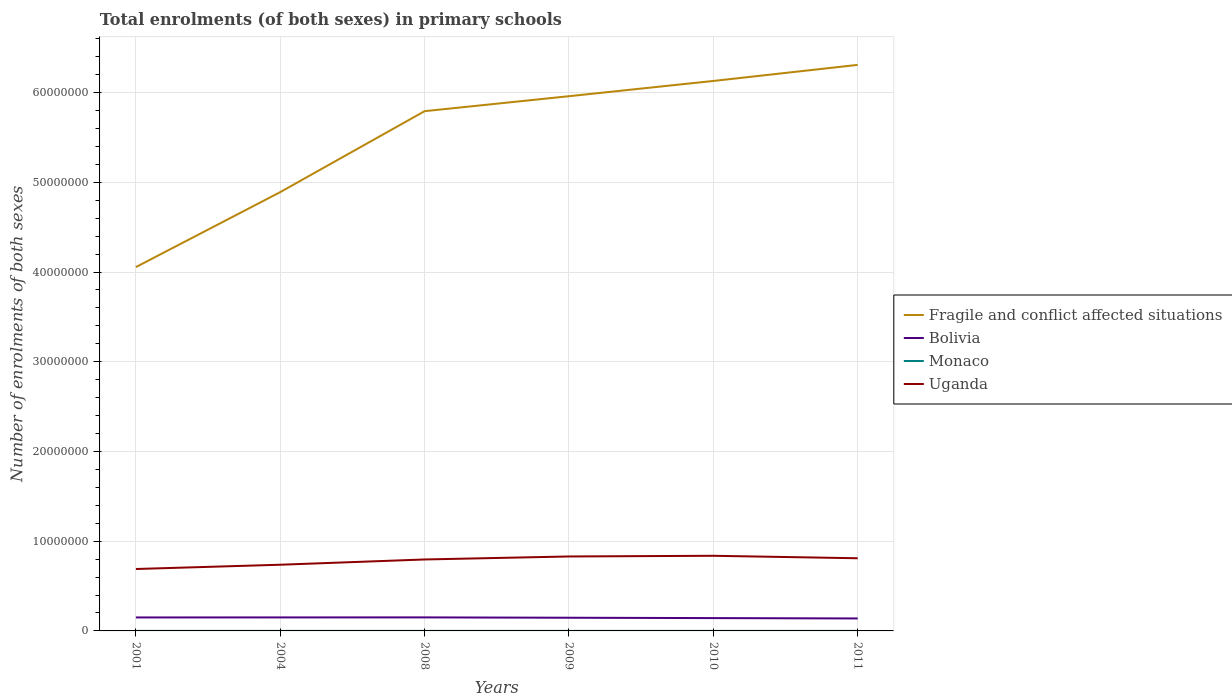How many different coloured lines are there?
Provide a short and direct response. 4. Across all years, what is the maximum number of enrolments in primary schools in Bolivia?
Make the answer very short. 1.39e+06. What is the total number of enrolments in primary schools in Monaco in the graph?
Provide a short and direct response. 92. What is the difference between the highest and the second highest number of enrolments in primary schools in Monaco?
Your response must be concise. 225. What is the difference between the highest and the lowest number of enrolments in primary schools in Monaco?
Offer a very short reply. 2. Is the number of enrolments in primary schools in Uganda strictly greater than the number of enrolments in primary schools in Bolivia over the years?
Offer a terse response. No. How many lines are there?
Offer a very short reply. 4. How many years are there in the graph?
Your answer should be very brief. 6. Does the graph contain grids?
Your answer should be compact. Yes. Where does the legend appear in the graph?
Offer a terse response. Center right. How many legend labels are there?
Offer a terse response. 4. What is the title of the graph?
Give a very brief answer. Total enrolments (of both sexes) in primary schools. What is the label or title of the Y-axis?
Give a very brief answer. Number of enrolments of both sexes. What is the Number of enrolments of both sexes of Fragile and conflict affected situations in 2001?
Offer a terse response. 4.05e+07. What is the Number of enrolments of both sexes of Bolivia in 2001?
Provide a succinct answer. 1.50e+06. What is the Number of enrolments of both sexes in Monaco in 2001?
Make the answer very short. 1985. What is the Number of enrolments of both sexes in Uganda in 2001?
Give a very brief answer. 6.90e+06. What is the Number of enrolments of both sexes in Fragile and conflict affected situations in 2004?
Offer a terse response. 4.89e+07. What is the Number of enrolments of both sexes in Bolivia in 2004?
Provide a short and direct response. 1.50e+06. What is the Number of enrolments of both sexes in Monaco in 2004?
Your response must be concise. 1831. What is the Number of enrolments of both sexes in Uganda in 2004?
Provide a short and direct response. 7.38e+06. What is the Number of enrolments of both sexes in Fragile and conflict affected situations in 2008?
Offer a very short reply. 5.79e+07. What is the Number of enrolments of both sexes in Bolivia in 2008?
Keep it short and to the point. 1.51e+06. What is the Number of enrolments of both sexes of Monaco in 2008?
Provide a succinct answer. 1852. What is the Number of enrolments of both sexes in Uganda in 2008?
Give a very brief answer. 7.96e+06. What is the Number of enrolments of both sexes in Fragile and conflict affected situations in 2009?
Your answer should be compact. 5.96e+07. What is the Number of enrolments of both sexes in Bolivia in 2009?
Ensure brevity in your answer.  1.47e+06. What is the Number of enrolments of both sexes of Monaco in 2009?
Provide a succinct answer. 1837. What is the Number of enrolments of both sexes in Uganda in 2009?
Your answer should be very brief. 8.30e+06. What is the Number of enrolments of both sexes of Fragile and conflict affected situations in 2010?
Provide a short and direct response. 6.13e+07. What is the Number of enrolments of both sexes of Bolivia in 2010?
Offer a very short reply. 1.43e+06. What is the Number of enrolments of both sexes in Monaco in 2010?
Keep it short and to the point. 1820. What is the Number of enrolments of both sexes of Uganda in 2010?
Offer a terse response. 8.37e+06. What is the Number of enrolments of both sexes of Fragile and conflict affected situations in 2011?
Provide a succinct answer. 6.31e+07. What is the Number of enrolments of both sexes in Bolivia in 2011?
Make the answer very short. 1.39e+06. What is the Number of enrolments of both sexes in Monaco in 2011?
Ensure brevity in your answer.  1760. What is the Number of enrolments of both sexes in Uganda in 2011?
Ensure brevity in your answer.  8.10e+06. Across all years, what is the maximum Number of enrolments of both sexes of Fragile and conflict affected situations?
Offer a terse response. 6.31e+07. Across all years, what is the maximum Number of enrolments of both sexes in Bolivia?
Offer a very short reply. 1.51e+06. Across all years, what is the maximum Number of enrolments of both sexes in Monaco?
Ensure brevity in your answer.  1985. Across all years, what is the maximum Number of enrolments of both sexes in Uganda?
Your answer should be very brief. 8.37e+06. Across all years, what is the minimum Number of enrolments of both sexes of Fragile and conflict affected situations?
Ensure brevity in your answer.  4.05e+07. Across all years, what is the minimum Number of enrolments of both sexes of Bolivia?
Provide a succinct answer. 1.39e+06. Across all years, what is the minimum Number of enrolments of both sexes of Monaco?
Give a very brief answer. 1760. Across all years, what is the minimum Number of enrolments of both sexes of Uganda?
Your answer should be very brief. 6.90e+06. What is the total Number of enrolments of both sexes in Fragile and conflict affected situations in the graph?
Keep it short and to the point. 3.31e+08. What is the total Number of enrolments of both sexes of Bolivia in the graph?
Make the answer very short. 8.80e+06. What is the total Number of enrolments of both sexes of Monaco in the graph?
Make the answer very short. 1.11e+04. What is the total Number of enrolments of both sexes of Uganda in the graph?
Make the answer very short. 4.70e+07. What is the difference between the Number of enrolments of both sexes of Fragile and conflict affected situations in 2001 and that in 2004?
Provide a short and direct response. -8.36e+06. What is the difference between the Number of enrolments of both sexes in Bolivia in 2001 and that in 2004?
Offer a terse response. -3453. What is the difference between the Number of enrolments of both sexes of Monaco in 2001 and that in 2004?
Keep it short and to the point. 154. What is the difference between the Number of enrolments of both sexes of Uganda in 2001 and that in 2004?
Provide a succinct answer. -4.76e+05. What is the difference between the Number of enrolments of both sexes of Fragile and conflict affected situations in 2001 and that in 2008?
Offer a terse response. -1.74e+07. What is the difference between the Number of enrolments of both sexes in Bolivia in 2001 and that in 2008?
Your answer should be compact. -7349. What is the difference between the Number of enrolments of both sexes of Monaco in 2001 and that in 2008?
Your answer should be compact. 133. What is the difference between the Number of enrolments of both sexes in Uganda in 2001 and that in 2008?
Keep it short and to the point. -1.06e+06. What is the difference between the Number of enrolments of both sexes of Fragile and conflict affected situations in 2001 and that in 2009?
Offer a very short reply. -1.90e+07. What is the difference between the Number of enrolments of both sexes in Bolivia in 2001 and that in 2009?
Provide a short and direct response. 3.15e+04. What is the difference between the Number of enrolments of both sexes of Monaco in 2001 and that in 2009?
Offer a terse response. 148. What is the difference between the Number of enrolments of both sexes of Uganda in 2001 and that in 2009?
Keep it short and to the point. -1.40e+06. What is the difference between the Number of enrolments of both sexes in Fragile and conflict affected situations in 2001 and that in 2010?
Your answer should be very brief. -2.07e+07. What is the difference between the Number of enrolments of both sexes in Bolivia in 2001 and that in 2010?
Your answer should be very brief. 7.20e+04. What is the difference between the Number of enrolments of both sexes of Monaco in 2001 and that in 2010?
Provide a succinct answer. 165. What is the difference between the Number of enrolments of both sexes in Uganda in 2001 and that in 2010?
Your answer should be compact. -1.47e+06. What is the difference between the Number of enrolments of both sexes in Fragile and conflict affected situations in 2001 and that in 2011?
Make the answer very short. -2.25e+07. What is the difference between the Number of enrolments of both sexes of Bolivia in 2001 and that in 2011?
Keep it short and to the point. 1.11e+05. What is the difference between the Number of enrolments of both sexes of Monaco in 2001 and that in 2011?
Your response must be concise. 225. What is the difference between the Number of enrolments of both sexes of Uganda in 2001 and that in 2011?
Give a very brief answer. -1.20e+06. What is the difference between the Number of enrolments of both sexes of Fragile and conflict affected situations in 2004 and that in 2008?
Keep it short and to the point. -9.02e+06. What is the difference between the Number of enrolments of both sexes in Bolivia in 2004 and that in 2008?
Keep it short and to the point. -3896. What is the difference between the Number of enrolments of both sexes in Monaco in 2004 and that in 2008?
Make the answer very short. -21. What is the difference between the Number of enrolments of both sexes of Uganda in 2004 and that in 2008?
Provide a short and direct response. -5.87e+05. What is the difference between the Number of enrolments of both sexes in Fragile and conflict affected situations in 2004 and that in 2009?
Offer a terse response. -1.07e+07. What is the difference between the Number of enrolments of both sexes of Bolivia in 2004 and that in 2009?
Your response must be concise. 3.50e+04. What is the difference between the Number of enrolments of both sexes of Monaco in 2004 and that in 2009?
Your answer should be very brief. -6. What is the difference between the Number of enrolments of both sexes of Uganda in 2004 and that in 2009?
Your answer should be compact. -9.20e+05. What is the difference between the Number of enrolments of both sexes of Fragile and conflict affected situations in 2004 and that in 2010?
Your answer should be very brief. -1.24e+07. What is the difference between the Number of enrolments of both sexes in Bolivia in 2004 and that in 2010?
Give a very brief answer. 7.54e+04. What is the difference between the Number of enrolments of both sexes in Uganda in 2004 and that in 2010?
Provide a short and direct response. -9.97e+05. What is the difference between the Number of enrolments of both sexes in Fragile and conflict affected situations in 2004 and that in 2011?
Your answer should be very brief. -1.42e+07. What is the difference between the Number of enrolments of both sexes of Bolivia in 2004 and that in 2011?
Your answer should be very brief. 1.15e+05. What is the difference between the Number of enrolments of both sexes in Monaco in 2004 and that in 2011?
Make the answer very short. 71. What is the difference between the Number of enrolments of both sexes of Uganda in 2004 and that in 2011?
Your response must be concise. -7.21e+05. What is the difference between the Number of enrolments of both sexes of Fragile and conflict affected situations in 2008 and that in 2009?
Offer a very short reply. -1.67e+06. What is the difference between the Number of enrolments of both sexes of Bolivia in 2008 and that in 2009?
Ensure brevity in your answer.  3.89e+04. What is the difference between the Number of enrolments of both sexes of Monaco in 2008 and that in 2009?
Your answer should be compact. 15. What is the difference between the Number of enrolments of both sexes of Uganda in 2008 and that in 2009?
Keep it short and to the point. -3.34e+05. What is the difference between the Number of enrolments of both sexes in Fragile and conflict affected situations in 2008 and that in 2010?
Make the answer very short. -3.37e+06. What is the difference between the Number of enrolments of both sexes of Bolivia in 2008 and that in 2010?
Ensure brevity in your answer.  7.93e+04. What is the difference between the Number of enrolments of both sexes in Monaco in 2008 and that in 2010?
Provide a short and direct response. 32. What is the difference between the Number of enrolments of both sexes of Uganda in 2008 and that in 2010?
Give a very brief answer. -4.11e+05. What is the difference between the Number of enrolments of both sexes of Fragile and conflict affected situations in 2008 and that in 2011?
Provide a short and direct response. -5.16e+06. What is the difference between the Number of enrolments of both sexes of Bolivia in 2008 and that in 2011?
Keep it short and to the point. 1.19e+05. What is the difference between the Number of enrolments of both sexes in Monaco in 2008 and that in 2011?
Offer a very short reply. 92. What is the difference between the Number of enrolments of both sexes of Uganda in 2008 and that in 2011?
Your answer should be compact. -1.34e+05. What is the difference between the Number of enrolments of both sexes of Fragile and conflict affected situations in 2009 and that in 2010?
Your answer should be very brief. -1.70e+06. What is the difference between the Number of enrolments of both sexes in Bolivia in 2009 and that in 2010?
Ensure brevity in your answer.  4.04e+04. What is the difference between the Number of enrolments of both sexes in Uganda in 2009 and that in 2010?
Make the answer very short. -7.69e+04. What is the difference between the Number of enrolments of both sexes in Fragile and conflict affected situations in 2009 and that in 2011?
Your response must be concise. -3.49e+06. What is the difference between the Number of enrolments of both sexes of Bolivia in 2009 and that in 2011?
Offer a very short reply. 7.98e+04. What is the difference between the Number of enrolments of both sexes of Uganda in 2009 and that in 2011?
Keep it short and to the point. 2.00e+05. What is the difference between the Number of enrolments of both sexes of Fragile and conflict affected situations in 2010 and that in 2011?
Your answer should be very brief. -1.79e+06. What is the difference between the Number of enrolments of both sexes in Bolivia in 2010 and that in 2011?
Keep it short and to the point. 3.94e+04. What is the difference between the Number of enrolments of both sexes in Monaco in 2010 and that in 2011?
Give a very brief answer. 60. What is the difference between the Number of enrolments of both sexes of Uganda in 2010 and that in 2011?
Make the answer very short. 2.76e+05. What is the difference between the Number of enrolments of both sexes of Fragile and conflict affected situations in 2001 and the Number of enrolments of both sexes of Bolivia in 2004?
Ensure brevity in your answer.  3.90e+07. What is the difference between the Number of enrolments of both sexes in Fragile and conflict affected situations in 2001 and the Number of enrolments of both sexes in Monaco in 2004?
Your answer should be very brief. 4.05e+07. What is the difference between the Number of enrolments of both sexes in Fragile and conflict affected situations in 2001 and the Number of enrolments of both sexes in Uganda in 2004?
Make the answer very short. 3.32e+07. What is the difference between the Number of enrolments of both sexes of Bolivia in 2001 and the Number of enrolments of both sexes of Monaco in 2004?
Offer a very short reply. 1.50e+06. What is the difference between the Number of enrolments of both sexes of Bolivia in 2001 and the Number of enrolments of both sexes of Uganda in 2004?
Give a very brief answer. -5.88e+06. What is the difference between the Number of enrolments of both sexes in Monaco in 2001 and the Number of enrolments of both sexes in Uganda in 2004?
Your answer should be compact. -7.38e+06. What is the difference between the Number of enrolments of both sexes of Fragile and conflict affected situations in 2001 and the Number of enrolments of both sexes of Bolivia in 2008?
Ensure brevity in your answer.  3.90e+07. What is the difference between the Number of enrolments of both sexes of Fragile and conflict affected situations in 2001 and the Number of enrolments of both sexes of Monaco in 2008?
Offer a very short reply. 4.05e+07. What is the difference between the Number of enrolments of both sexes in Fragile and conflict affected situations in 2001 and the Number of enrolments of both sexes in Uganda in 2008?
Provide a short and direct response. 3.26e+07. What is the difference between the Number of enrolments of both sexes in Bolivia in 2001 and the Number of enrolments of both sexes in Monaco in 2008?
Ensure brevity in your answer.  1.50e+06. What is the difference between the Number of enrolments of both sexes of Bolivia in 2001 and the Number of enrolments of both sexes of Uganda in 2008?
Your answer should be very brief. -6.46e+06. What is the difference between the Number of enrolments of both sexes of Monaco in 2001 and the Number of enrolments of both sexes of Uganda in 2008?
Ensure brevity in your answer.  -7.96e+06. What is the difference between the Number of enrolments of both sexes of Fragile and conflict affected situations in 2001 and the Number of enrolments of both sexes of Bolivia in 2009?
Offer a very short reply. 3.91e+07. What is the difference between the Number of enrolments of both sexes of Fragile and conflict affected situations in 2001 and the Number of enrolments of both sexes of Monaco in 2009?
Provide a succinct answer. 4.05e+07. What is the difference between the Number of enrolments of both sexes in Fragile and conflict affected situations in 2001 and the Number of enrolments of both sexes in Uganda in 2009?
Your answer should be compact. 3.23e+07. What is the difference between the Number of enrolments of both sexes of Bolivia in 2001 and the Number of enrolments of both sexes of Monaco in 2009?
Make the answer very short. 1.50e+06. What is the difference between the Number of enrolments of both sexes of Bolivia in 2001 and the Number of enrolments of both sexes of Uganda in 2009?
Ensure brevity in your answer.  -6.80e+06. What is the difference between the Number of enrolments of both sexes in Monaco in 2001 and the Number of enrolments of both sexes in Uganda in 2009?
Offer a terse response. -8.30e+06. What is the difference between the Number of enrolments of both sexes of Fragile and conflict affected situations in 2001 and the Number of enrolments of both sexes of Bolivia in 2010?
Offer a very short reply. 3.91e+07. What is the difference between the Number of enrolments of both sexes in Fragile and conflict affected situations in 2001 and the Number of enrolments of both sexes in Monaco in 2010?
Your response must be concise. 4.05e+07. What is the difference between the Number of enrolments of both sexes of Fragile and conflict affected situations in 2001 and the Number of enrolments of both sexes of Uganda in 2010?
Provide a succinct answer. 3.22e+07. What is the difference between the Number of enrolments of both sexes in Bolivia in 2001 and the Number of enrolments of both sexes in Monaco in 2010?
Offer a very short reply. 1.50e+06. What is the difference between the Number of enrolments of both sexes in Bolivia in 2001 and the Number of enrolments of both sexes in Uganda in 2010?
Offer a very short reply. -6.87e+06. What is the difference between the Number of enrolments of both sexes in Monaco in 2001 and the Number of enrolments of both sexes in Uganda in 2010?
Offer a very short reply. -8.37e+06. What is the difference between the Number of enrolments of both sexes in Fragile and conflict affected situations in 2001 and the Number of enrolments of both sexes in Bolivia in 2011?
Offer a terse response. 3.92e+07. What is the difference between the Number of enrolments of both sexes of Fragile and conflict affected situations in 2001 and the Number of enrolments of both sexes of Monaco in 2011?
Ensure brevity in your answer.  4.05e+07. What is the difference between the Number of enrolments of both sexes in Fragile and conflict affected situations in 2001 and the Number of enrolments of both sexes in Uganda in 2011?
Your answer should be very brief. 3.25e+07. What is the difference between the Number of enrolments of both sexes of Bolivia in 2001 and the Number of enrolments of both sexes of Monaco in 2011?
Your answer should be very brief. 1.50e+06. What is the difference between the Number of enrolments of both sexes in Bolivia in 2001 and the Number of enrolments of both sexes in Uganda in 2011?
Your response must be concise. -6.60e+06. What is the difference between the Number of enrolments of both sexes in Monaco in 2001 and the Number of enrolments of both sexes in Uganda in 2011?
Your response must be concise. -8.10e+06. What is the difference between the Number of enrolments of both sexes in Fragile and conflict affected situations in 2004 and the Number of enrolments of both sexes in Bolivia in 2008?
Offer a terse response. 4.74e+07. What is the difference between the Number of enrolments of both sexes in Fragile and conflict affected situations in 2004 and the Number of enrolments of both sexes in Monaco in 2008?
Your response must be concise. 4.89e+07. What is the difference between the Number of enrolments of both sexes of Fragile and conflict affected situations in 2004 and the Number of enrolments of both sexes of Uganda in 2008?
Provide a short and direct response. 4.09e+07. What is the difference between the Number of enrolments of both sexes of Bolivia in 2004 and the Number of enrolments of both sexes of Monaco in 2008?
Offer a very short reply. 1.50e+06. What is the difference between the Number of enrolments of both sexes of Bolivia in 2004 and the Number of enrolments of both sexes of Uganda in 2008?
Your answer should be compact. -6.46e+06. What is the difference between the Number of enrolments of both sexes of Monaco in 2004 and the Number of enrolments of both sexes of Uganda in 2008?
Your answer should be very brief. -7.96e+06. What is the difference between the Number of enrolments of both sexes of Fragile and conflict affected situations in 2004 and the Number of enrolments of both sexes of Bolivia in 2009?
Make the answer very short. 4.74e+07. What is the difference between the Number of enrolments of both sexes of Fragile and conflict affected situations in 2004 and the Number of enrolments of both sexes of Monaco in 2009?
Your answer should be compact. 4.89e+07. What is the difference between the Number of enrolments of both sexes in Fragile and conflict affected situations in 2004 and the Number of enrolments of both sexes in Uganda in 2009?
Provide a succinct answer. 4.06e+07. What is the difference between the Number of enrolments of both sexes in Bolivia in 2004 and the Number of enrolments of both sexes in Monaco in 2009?
Your response must be concise. 1.50e+06. What is the difference between the Number of enrolments of both sexes of Bolivia in 2004 and the Number of enrolments of both sexes of Uganda in 2009?
Provide a short and direct response. -6.79e+06. What is the difference between the Number of enrolments of both sexes of Monaco in 2004 and the Number of enrolments of both sexes of Uganda in 2009?
Provide a short and direct response. -8.30e+06. What is the difference between the Number of enrolments of both sexes in Fragile and conflict affected situations in 2004 and the Number of enrolments of both sexes in Bolivia in 2010?
Provide a succinct answer. 4.75e+07. What is the difference between the Number of enrolments of both sexes in Fragile and conflict affected situations in 2004 and the Number of enrolments of both sexes in Monaco in 2010?
Keep it short and to the point. 4.89e+07. What is the difference between the Number of enrolments of both sexes in Fragile and conflict affected situations in 2004 and the Number of enrolments of both sexes in Uganda in 2010?
Offer a terse response. 4.05e+07. What is the difference between the Number of enrolments of both sexes in Bolivia in 2004 and the Number of enrolments of both sexes in Monaco in 2010?
Make the answer very short. 1.50e+06. What is the difference between the Number of enrolments of both sexes of Bolivia in 2004 and the Number of enrolments of both sexes of Uganda in 2010?
Your response must be concise. -6.87e+06. What is the difference between the Number of enrolments of both sexes of Monaco in 2004 and the Number of enrolments of both sexes of Uganda in 2010?
Keep it short and to the point. -8.37e+06. What is the difference between the Number of enrolments of both sexes in Fragile and conflict affected situations in 2004 and the Number of enrolments of both sexes in Bolivia in 2011?
Provide a short and direct response. 4.75e+07. What is the difference between the Number of enrolments of both sexes in Fragile and conflict affected situations in 2004 and the Number of enrolments of both sexes in Monaco in 2011?
Give a very brief answer. 4.89e+07. What is the difference between the Number of enrolments of both sexes in Fragile and conflict affected situations in 2004 and the Number of enrolments of both sexes in Uganda in 2011?
Ensure brevity in your answer.  4.08e+07. What is the difference between the Number of enrolments of both sexes in Bolivia in 2004 and the Number of enrolments of both sexes in Monaco in 2011?
Keep it short and to the point. 1.50e+06. What is the difference between the Number of enrolments of both sexes of Bolivia in 2004 and the Number of enrolments of both sexes of Uganda in 2011?
Your answer should be compact. -6.59e+06. What is the difference between the Number of enrolments of both sexes in Monaco in 2004 and the Number of enrolments of both sexes in Uganda in 2011?
Make the answer very short. -8.10e+06. What is the difference between the Number of enrolments of both sexes in Fragile and conflict affected situations in 2008 and the Number of enrolments of both sexes in Bolivia in 2009?
Give a very brief answer. 5.65e+07. What is the difference between the Number of enrolments of both sexes in Fragile and conflict affected situations in 2008 and the Number of enrolments of both sexes in Monaco in 2009?
Provide a short and direct response. 5.79e+07. What is the difference between the Number of enrolments of both sexes in Fragile and conflict affected situations in 2008 and the Number of enrolments of both sexes in Uganda in 2009?
Give a very brief answer. 4.96e+07. What is the difference between the Number of enrolments of both sexes in Bolivia in 2008 and the Number of enrolments of both sexes in Monaco in 2009?
Keep it short and to the point. 1.51e+06. What is the difference between the Number of enrolments of both sexes in Bolivia in 2008 and the Number of enrolments of both sexes in Uganda in 2009?
Offer a terse response. -6.79e+06. What is the difference between the Number of enrolments of both sexes in Monaco in 2008 and the Number of enrolments of both sexes in Uganda in 2009?
Provide a succinct answer. -8.30e+06. What is the difference between the Number of enrolments of both sexes in Fragile and conflict affected situations in 2008 and the Number of enrolments of both sexes in Bolivia in 2010?
Keep it short and to the point. 5.65e+07. What is the difference between the Number of enrolments of both sexes in Fragile and conflict affected situations in 2008 and the Number of enrolments of both sexes in Monaco in 2010?
Keep it short and to the point. 5.79e+07. What is the difference between the Number of enrolments of both sexes in Fragile and conflict affected situations in 2008 and the Number of enrolments of both sexes in Uganda in 2010?
Keep it short and to the point. 4.96e+07. What is the difference between the Number of enrolments of both sexes in Bolivia in 2008 and the Number of enrolments of both sexes in Monaco in 2010?
Make the answer very short. 1.51e+06. What is the difference between the Number of enrolments of both sexes in Bolivia in 2008 and the Number of enrolments of both sexes in Uganda in 2010?
Make the answer very short. -6.87e+06. What is the difference between the Number of enrolments of both sexes in Monaco in 2008 and the Number of enrolments of both sexes in Uganda in 2010?
Keep it short and to the point. -8.37e+06. What is the difference between the Number of enrolments of both sexes of Fragile and conflict affected situations in 2008 and the Number of enrolments of both sexes of Bolivia in 2011?
Your response must be concise. 5.65e+07. What is the difference between the Number of enrolments of both sexes in Fragile and conflict affected situations in 2008 and the Number of enrolments of both sexes in Monaco in 2011?
Your answer should be compact. 5.79e+07. What is the difference between the Number of enrolments of both sexes of Fragile and conflict affected situations in 2008 and the Number of enrolments of both sexes of Uganda in 2011?
Your response must be concise. 4.98e+07. What is the difference between the Number of enrolments of both sexes of Bolivia in 2008 and the Number of enrolments of both sexes of Monaco in 2011?
Your response must be concise. 1.51e+06. What is the difference between the Number of enrolments of both sexes of Bolivia in 2008 and the Number of enrolments of both sexes of Uganda in 2011?
Make the answer very short. -6.59e+06. What is the difference between the Number of enrolments of both sexes of Monaco in 2008 and the Number of enrolments of both sexes of Uganda in 2011?
Make the answer very short. -8.10e+06. What is the difference between the Number of enrolments of both sexes in Fragile and conflict affected situations in 2009 and the Number of enrolments of both sexes in Bolivia in 2010?
Keep it short and to the point. 5.82e+07. What is the difference between the Number of enrolments of both sexes in Fragile and conflict affected situations in 2009 and the Number of enrolments of both sexes in Monaco in 2010?
Offer a very short reply. 5.96e+07. What is the difference between the Number of enrolments of both sexes in Fragile and conflict affected situations in 2009 and the Number of enrolments of both sexes in Uganda in 2010?
Your answer should be very brief. 5.12e+07. What is the difference between the Number of enrolments of both sexes of Bolivia in 2009 and the Number of enrolments of both sexes of Monaco in 2010?
Your response must be concise. 1.47e+06. What is the difference between the Number of enrolments of both sexes in Bolivia in 2009 and the Number of enrolments of both sexes in Uganda in 2010?
Your answer should be very brief. -6.91e+06. What is the difference between the Number of enrolments of both sexes of Monaco in 2009 and the Number of enrolments of both sexes of Uganda in 2010?
Make the answer very short. -8.37e+06. What is the difference between the Number of enrolments of both sexes of Fragile and conflict affected situations in 2009 and the Number of enrolments of both sexes of Bolivia in 2011?
Your answer should be compact. 5.82e+07. What is the difference between the Number of enrolments of both sexes of Fragile and conflict affected situations in 2009 and the Number of enrolments of both sexes of Monaco in 2011?
Offer a very short reply. 5.96e+07. What is the difference between the Number of enrolments of both sexes of Fragile and conflict affected situations in 2009 and the Number of enrolments of both sexes of Uganda in 2011?
Keep it short and to the point. 5.15e+07. What is the difference between the Number of enrolments of both sexes in Bolivia in 2009 and the Number of enrolments of both sexes in Monaco in 2011?
Keep it short and to the point. 1.47e+06. What is the difference between the Number of enrolments of both sexes of Bolivia in 2009 and the Number of enrolments of both sexes of Uganda in 2011?
Ensure brevity in your answer.  -6.63e+06. What is the difference between the Number of enrolments of both sexes of Monaco in 2009 and the Number of enrolments of both sexes of Uganda in 2011?
Your response must be concise. -8.10e+06. What is the difference between the Number of enrolments of both sexes of Fragile and conflict affected situations in 2010 and the Number of enrolments of both sexes of Bolivia in 2011?
Give a very brief answer. 5.99e+07. What is the difference between the Number of enrolments of both sexes of Fragile and conflict affected situations in 2010 and the Number of enrolments of both sexes of Monaco in 2011?
Make the answer very short. 6.13e+07. What is the difference between the Number of enrolments of both sexes in Fragile and conflict affected situations in 2010 and the Number of enrolments of both sexes in Uganda in 2011?
Your response must be concise. 5.32e+07. What is the difference between the Number of enrolments of both sexes in Bolivia in 2010 and the Number of enrolments of both sexes in Monaco in 2011?
Ensure brevity in your answer.  1.43e+06. What is the difference between the Number of enrolments of both sexes in Bolivia in 2010 and the Number of enrolments of both sexes in Uganda in 2011?
Keep it short and to the point. -6.67e+06. What is the difference between the Number of enrolments of both sexes of Monaco in 2010 and the Number of enrolments of both sexes of Uganda in 2011?
Keep it short and to the point. -8.10e+06. What is the average Number of enrolments of both sexes in Fragile and conflict affected situations per year?
Your answer should be compact. 5.52e+07. What is the average Number of enrolments of both sexes of Bolivia per year?
Your answer should be compact. 1.47e+06. What is the average Number of enrolments of both sexes of Monaco per year?
Offer a terse response. 1847.5. What is the average Number of enrolments of both sexes in Uganda per year?
Provide a succinct answer. 7.84e+06. In the year 2001, what is the difference between the Number of enrolments of both sexes of Fragile and conflict affected situations and Number of enrolments of both sexes of Bolivia?
Give a very brief answer. 3.90e+07. In the year 2001, what is the difference between the Number of enrolments of both sexes in Fragile and conflict affected situations and Number of enrolments of both sexes in Monaco?
Ensure brevity in your answer.  4.05e+07. In the year 2001, what is the difference between the Number of enrolments of both sexes of Fragile and conflict affected situations and Number of enrolments of both sexes of Uganda?
Your response must be concise. 3.36e+07. In the year 2001, what is the difference between the Number of enrolments of both sexes of Bolivia and Number of enrolments of both sexes of Monaco?
Make the answer very short. 1.50e+06. In the year 2001, what is the difference between the Number of enrolments of both sexes of Bolivia and Number of enrolments of both sexes of Uganda?
Ensure brevity in your answer.  -5.40e+06. In the year 2001, what is the difference between the Number of enrolments of both sexes of Monaco and Number of enrolments of both sexes of Uganda?
Your answer should be compact. -6.90e+06. In the year 2004, what is the difference between the Number of enrolments of both sexes in Fragile and conflict affected situations and Number of enrolments of both sexes in Bolivia?
Offer a terse response. 4.74e+07. In the year 2004, what is the difference between the Number of enrolments of both sexes of Fragile and conflict affected situations and Number of enrolments of both sexes of Monaco?
Offer a very short reply. 4.89e+07. In the year 2004, what is the difference between the Number of enrolments of both sexes of Fragile and conflict affected situations and Number of enrolments of both sexes of Uganda?
Your response must be concise. 4.15e+07. In the year 2004, what is the difference between the Number of enrolments of both sexes in Bolivia and Number of enrolments of both sexes in Monaco?
Your answer should be very brief. 1.50e+06. In the year 2004, what is the difference between the Number of enrolments of both sexes in Bolivia and Number of enrolments of both sexes in Uganda?
Your answer should be very brief. -5.87e+06. In the year 2004, what is the difference between the Number of enrolments of both sexes of Monaco and Number of enrolments of both sexes of Uganda?
Ensure brevity in your answer.  -7.38e+06. In the year 2008, what is the difference between the Number of enrolments of both sexes in Fragile and conflict affected situations and Number of enrolments of both sexes in Bolivia?
Ensure brevity in your answer.  5.64e+07. In the year 2008, what is the difference between the Number of enrolments of both sexes in Fragile and conflict affected situations and Number of enrolments of both sexes in Monaco?
Provide a short and direct response. 5.79e+07. In the year 2008, what is the difference between the Number of enrolments of both sexes of Fragile and conflict affected situations and Number of enrolments of both sexes of Uganda?
Provide a short and direct response. 5.00e+07. In the year 2008, what is the difference between the Number of enrolments of both sexes in Bolivia and Number of enrolments of both sexes in Monaco?
Offer a terse response. 1.51e+06. In the year 2008, what is the difference between the Number of enrolments of both sexes of Bolivia and Number of enrolments of both sexes of Uganda?
Provide a succinct answer. -6.46e+06. In the year 2008, what is the difference between the Number of enrolments of both sexes of Monaco and Number of enrolments of both sexes of Uganda?
Your answer should be very brief. -7.96e+06. In the year 2009, what is the difference between the Number of enrolments of both sexes of Fragile and conflict affected situations and Number of enrolments of both sexes of Bolivia?
Provide a short and direct response. 5.81e+07. In the year 2009, what is the difference between the Number of enrolments of both sexes in Fragile and conflict affected situations and Number of enrolments of both sexes in Monaco?
Provide a succinct answer. 5.96e+07. In the year 2009, what is the difference between the Number of enrolments of both sexes in Fragile and conflict affected situations and Number of enrolments of both sexes in Uganda?
Give a very brief answer. 5.13e+07. In the year 2009, what is the difference between the Number of enrolments of both sexes in Bolivia and Number of enrolments of both sexes in Monaco?
Your answer should be compact. 1.47e+06. In the year 2009, what is the difference between the Number of enrolments of both sexes in Bolivia and Number of enrolments of both sexes in Uganda?
Offer a very short reply. -6.83e+06. In the year 2009, what is the difference between the Number of enrolments of both sexes in Monaco and Number of enrolments of both sexes in Uganda?
Your answer should be compact. -8.30e+06. In the year 2010, what is the difference between the Number of enrolments of both sexes of Fragile and conflict affected situations and Number of enrolments of both sexes of Bolivia?
Your response must be concise. 5.99e+07. In the year 2010, what is the difference between the Number of enrolments of both sexes of Fragile and conflict affected situations and Number of enrolments of both sexes of Monaco?
Your answer should be very brief. 6.13e+07. In the year 2010, what is the difference between the Number of enrolments of both sexes of Fragile and conflict affected situations and Number of enrolments of both sexes of Uganda?
Make the answer very short. 5.29e+07. In the year 2010, what is the difference between the Number of enrolments of both sexes of Bolivia and Number of enrolments of both sexes of Monaco?
Offer a very short reply. 1.43e+06. In the year 2010, what is the difference between the Number of enrolments of both sexes in Bolivia and Number of enrolments of both sexes in Uganda?
Provide a short and direct response. -6.95e+06. In the year 2010, what is the difference between the Number of enrolments of both sexes in Monaco and Number of enrolments of both sexes in Uganda?
Keep it short and to the point. -8.37e+06. In the year 2011, what is the difference between the Number of enrolments of both sexes of Fragile and conflict affected situations and Number of enrolments of both sexes of Bolivia?
Provide a succinct answer. 6.17e+07. In the year 2011, what is the difference between the Number of enrolments of both sexes of Fragile and conflict affected situations and Number of enrolments of both sexes of Monaco?
Make the answer very short. 6.31e+07. In the year 2011, what is the difference between the Number of enrolments of both sexes in Fragile and conflict affected situations and Number of enrolments of both sexes in Uganda?
Ensure brevity in your answer.  5.50e+07. In the year 2011, what is the difference between the Number of enrolments of both sexes in Bolivia and Number of enrolments of both sexes in Monaco?
Keep it short and to the point. 1.39e+06. In the year 2011, what is the difference between the Number of enrolments of both sexes in Bolivia and Number of enrolments of both sexes in Uganda?
Your answer should be compact. -6.71e+06. In the year 2011, what is the difference between the Number of enrolments of both sexes in Monaco and Number of enrolments of both sexes in Uganda?
Provide a short and direct response. -8.10e+06. What is the ratio of the Number of enrolments of both sexes of Fragile and conflict affected situations in 2001 to that in 2004?
Give a very brief answer. 0.83. What is the ratio of the Number of enrolments of both sexes of Monaco in 2001 to that in 2004?
Provide a succinct answer. 1.08. What is the ratio of the Number of enrolments of both sexes in Uganda in 2001 to that in 2004?
Your answer should be compact. 0.94. What is the ratio of the Number of enrolments of both sexes of Fragile and conflict affected situations in 2001 to that in 2008?
Your response must be concise. 0.7. What is the ratio of the Number of enrolments of both sexes in Monaco in 2001 to that in 2008?
Your answer should be very brief. 1.07. What is the ratio of the Number of enrolments of both sexes in Uganda in 2001 to that in 2008?
Your answer should be very brief. 0.87. What is the ratio of the Number of enrolments of both sexes of Fragile and conflict affected situations in 2001 to that in 2009?
Ensure brevity in your answer.  0.68. What is the ratio of the Number of enrolments of both sexes of Bolivia in 2001 to that in 2009?
Give a very brief answer. 1.02. What is the ratio of the Number of enrolments of both sexes in Monaco in 2001 to that in 2009?
Give a very brief answer. 1.08. What is the ratio of the Number of enrolments of both sexes of Uganda in 2001 to that in 2009?
Provide a short and direct response. 0.83. What is the ratio of the Number of enrolments of both sexes in Fragile and conflict affected situations in 2001 to that in 2010?
Your answer should be compact. 0.66. What is the ratio of the Number of enrolments of both sexes in Bolivia in 2001 to that in 2010?
Ensure brevity in your answer.  1.05. What is the ratio of the Number of enrolments of both sexes in Monaco in 2001 to that in 2010?
Ensure brevity in your answer.  1.09. What is the ratio of the Number of enrolments of both sexes of Uganda in 2001 to that in 2010?
Provide a short and direct response. 0.82. What is the ratio of the Number of enrolments of both sexes of Fragile and conflict affected situations in 2001 to that in 2011?
Make the answer very short. 0.64. What is the ratio of the Number of enrolments of both sexes in Bolivia in 2001 to that in 2011?
Offer a very short reply. 1.08. What is the ratio of the Number of enrolments of both sexes of Monaco in 2001 to that in 2011?
Make the answer very short. 1.13. What is the ratio of the Number of enrolments of both sexes in Uganda in 2001 to that in 2011?
Give a very brief answer. 0.85. What is the ratio of the Number of enrolments of both sexes in Fragile and conflict affected situations in 2004 to that in 2008?
Your answer should be very brief. 0.84. What is the ratio of the Number of enrolments of both sexes in Bolivia in 2004 to that in 2008?
Your answer should be compact. 1. What is the ratio of the Number of enrolments of both sexes in Monaco in 2004 to that in 2008?
Your answer should be compact. 0.99. What is the ratio of the Number of enrolments of both sexes in Uganda in 2004 to that in 2008?
Provide a succinct answer. 0.93. What is the ratio of the Number of enrolments of both sexes in Fragile and conflict affected situations in 2004 to that in 2009?
Your answer should be compact. 0.82. What is the ratio of the Number of enrolments of both sexes in Bolivia in 2004 to that in 2009?
Ensure brevity in your answer.  1.02. What is the ratio of the Number of enrolments of both sexes in Uganda in 2004 to that in 2009?
Provide a succinct answer. 0.89. What is the ratio of the Number of enrolments of both sexes of Fragile and conflict affected situations in 2004 to that in 2010?
Provide a succinct answer. 0.8. What is the ratio of the Number of enrolments of both sexes of Bolivia in 2004 to that in 2010?
Your response must be concise. 1.05. What is the ratio of the Number of enrolments of both sexes in Monaco in 2004 to that in 2010?
Make the answer very short. 1.01. What is the ratio of the Number of enrolments of both sexes in Uganda in 2004 to that in 2010?
Ensure brevity in your answer.  0.88. What is the ratio of the Number of enrolments of both sexes in Fragile and conflict affected situations in 2004 to that in 2011?
Provide a short and direct response. 0.78. What is the ratio of the Number of enrolments of both sexes of Bolivia in 2004 to that in 2011?
Ensure brevity in your answer.  1.08. What is the ratio of the Number of enrolments of both sexes of Monaco in 2004 to that in 2011?
Offer a very short reply. 1.04. What is the ratio of the Number of enrolments of both sexes in Uganda in 2004 to that in 2011?
Ensure brevity in your answer.  0.91. What is the ratio of the Number of enrolments of both sexes of Bolivia in 2008 to that in 2009?
Provide a short and direct response. 1.03. What is the ratio of the Number of enrolments of both sexes in Monaco in 2008 to that in 2009?
Your answer should be very brief. 1.01. What is the ratio of the Number of enrolments of both sexes of Uganda in 2008 to that in 2009?
Give a very brief answer. 0.96. What is the ratio of the Number of enrolments of both sexes in Fragile and conflict affected situations in 2008 to that in 2010?
Keep it short and to the point. 0.95. What is the ratio of the Number of enrolments of both sexes of Bolivia in 2008 to that in 2010?
Ensure brevity in your answer.  1.06. What is the ratio of the Number of enrolments of both sexes in Monaco in 2008 to that in 2010?
Offer a very short reply. 1.02. What is the ratio of the Number of enrolments of both sexes in Uganda in 2008 to that in 2010?
Your answer should be very brief. 0.95. What is the ratio of the Number of enrolments of both sexes of Fragile and conflict affected situations in 2008 to that in 2011?
Give a very brief answer. 0.92. What is the ratio of the Number of enrolments of both sexes of Bolivia in 2008 to that in 2011?
Your response must be concise. 1.09. What is the ratio of the Number of enrolments of both sexes of Monaco in 2008 to that in 2011?
Your answer should be very brief. 1.05. What is the ratio of the Number of enrolments of both sexes of Uganda in 2008 to that in 2011?
Make the answer very short. 0.98. What is the ratio of the Number of enrolments of both sexes in Fragile and conflict affected situations in 2009 to that in 2010?
Your answer should be compact. 0.97. What is the ratio of the Number of enrolments of both sexes in Bolivia in 2009 to that in 2010?
Your answer should be compact. 1.03. What is the ratio of the Number of enrolments of both sexes of Monaco in 2009 to that in 2010?
Give a very brief answer. 1.01. What is the ratio of the Number of enrolments of both sexes in Uganda in 2009 to that in 2010?
Your answer should be very brief. 0.99. What is the ratio of the Number of enrolments of both sexes of Fragile and conflict affected situations in 2009 to that in 2011?
Your answer should be compact. 0.94. What is the ratio of the Number of enrolments of both sexes in Bolivia in 2009 to that in 2011?
Keep it short and to the point. 1.06. What is the ratio of the Number of enrolments of both sexes in Monaco in 2009 to that in 2011?
Ensure brevity in your answer.  1.04. What is the ratio of the Number of enrolments of both sexes in Uganda in 2009 to that in 2011?
Make the answer very short. 1.02. What is the ratio of the Number of enrolments of both sexes of Fragile and conflict affected situations in 2010 to that in 2011?
Offer a very short reply. 0.97. What is the ratio of the Number of enrolments of both sexes of Bolivia in 2010 to that in 2011?
Your answer should be very brief. 1.03. What is the ratio of the Number of enrolments of both sexes of Monaco in 2010 to that in 2011?
Ensure brevity in your answer.  1.03. What is the ratio of the Number of enrolments of both sexes in Uganda in 2010 to that in 2011?
Ensure brevity in your answer.  1.03. What is the difference between the highest and the second highest Number of enrolments of both sexes of Fragile and conflict affected situations?
Provide a short and direct response. 1.79e+06. What is the difference between the highest and the second highest Number of enrolments of both sexes of Bolivia?
Give a very brief answer. 3896. What is the difference between the highest and the second highest Number of enrolments of both sexes of Monaco?
Make the answer very short. 133. What is the difference between the highest and the second highest Number of enrolments of both sexes of Uganda?
Your answer should be very brief. 7.69e+04. What is the difference between the highest and the lowest Number of enrolments of both sexes in Fragile and conflict affected situations?
Offer a very short reply. 2.25e+07. What is the difference between the highest and the lowest Number of enrolments of both sexes of Bolivia?
Give a very brief answer. 1.19e+05. What is the difference between the highest and the lowest Number of enrolments of both sexes of Monaco?
Provide a succinct answer. 225. What is the difference between the highest and the lowest Number of enrolments of both sexes of Uganda?
Ensure brevity in your answer.  1.47e+06. 